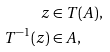Convert formula to latex. <formula><loc_0><loc_0><loc_500><loc_500>z & \in T ( A ) , \\ T ^ { - 1 } ( z ) & \in A ,</formula> 